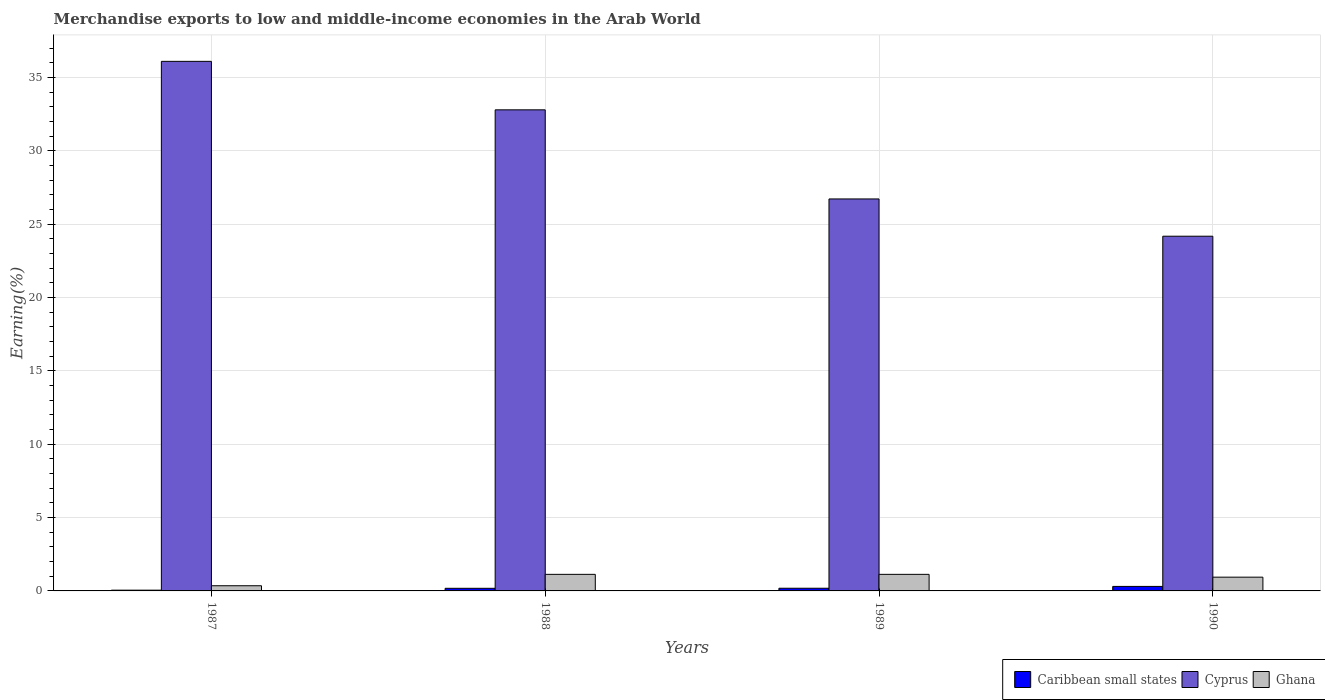Are the number of bars per tick equal to the number of legend labels?
Provide a short and direct response. Yes. Are the number of bars on each tick of the X-axis equal?
Offer a very short reply. Yes. In how many cases, is the number of bars for a given year not equal to the number of legend labels?
Provide a succinct answer. 0. What is the percentage of amount earned from merchandise exports in Ghana in 1989?
Your answer should be compact. 1.13. Across all years, what is the maximum percentage of amount earned from merchandise exports in Ghana?
Your response must be concise. 1.13. Across all years, what is the minimum percentage of amount earned from merchandise exports in Caribbean small states?
Your answer should be compact. 0.05. In which year was the percentage of amount earned from merchandise exports in Ghana minimum?
Provide a short and direct response. 1987. What is the total percentage of amount earned from merchandise exports in Caribbean small states in the graph?
Provide a succinct answer. 0.72. What is the difference between the percentage of amount earned from merchandise exports in Ghana in 1989 and that in 1990?
Ensure brevity in your answer.  0.19. What is the difference between the percentage of amount earned from merchandise exports in Ghana in 1988 and the percentage of amount earned from merchandise exports in Cyprus in 1989?
Your answer should be compact. -25.6. What is the average percentage of amount earned from merchandise exports in Cyprus per year?
Give a very brief answer. 29.95. In the year 1987, what is the difference between the percentage of amount earned from merchandise exports in Cyprus and percentage of amount earned from merchandise exports in Caribbean small states?
Keep it short and to the point. 36.06. What is the ratio of the percentage of amount earned from merchandise exports in Ghana in 1987 to that in 1988?
Ensure brevity in your answer.  0.31. Is the difference between the percentage of amount earned from merchandise exports in Cyprus in 1989 and 1990 greater than the difference between the percentage of amount earned from merchandise exports in Caribbean small states in 1989 and 1990?
Your answer should be compact. Yes. What is the difference between the highest and the second highest percentage of amount earned from merchandise exports in Cyprus?
Keep it short and to the point. 3.31. What is the difference between the highest and the lowest percentage of amount earned from merchandise exports in Ghana?
Your answer should be very brief. 0.78. In how many years, is the percentage of amount earned from merchandise exports in Caribbean small states greater than the average percentage of amount earned from merchandise exports in Caribbean small states taken over all years?
Give a very brief answer. 2. Is the sum of the percentage of amount earned from merchandise exports in Caribbean small states in 1987 and 1989 greater than the maximum percentage of amount earned from merchandise exports in Ghana across all years?
Ensure brevity in your answer.  No. What does the 3rd bar from the right in 1990 represents?
Your answer should be compact. Caribbean small states. Is it the case that in every year, the sum of the percentage of amount earned from merchandise exports in Caribbean small states and percentage of amount earned from merchandise exports in Cyprus is greater than the percentage of amount earned from merchandise exports in Ghana?
Keep it short and to the point. Yes. How many years are there in the graph?
Provide a short and direct response. 4. Does the graph contain any zero values?
Offer a very short reply. No. Where does the legend appear in the graph?
Your answer should be very brief. Bottom right. How are the legend labels stacked?
Make the answer very short. Horizontal. What is the title of the graph?
Your response must be concise. Merchandise exports to low and middle-income economies in the Arab World. Does "Lao PDR" appear as one of the legend labels in the graph?
Offer a terse response. No. What is the label or title of the Y-axis?
Ensure brevity in your answer.  Earning(%). What is the Earning(%) in Caribbean small states in 1987?
Provide a succinct answer. 0.05. What is the Earning(%) of Cyprus in 1987?
Keep it short and to the point. 36.11. What is the Earning(%) in Ghana in 1987?
Your answer should be very brief. 0.35. What is the Earning(%) in Caribbean small states in 1988?
Your answer should be very brief. 0.18. What is the Earning(%) of Cyprus in 1988?
Keep it short and to the point. 32.8. What is the Earning(%) of Ghana in 1988?
Provide a succinct answer. 1.13. What is the Earning(%) in Caribbean small states in 1989?
Offer a terse response. 0.18. What is the Earning(%) in Cyprus in 1989?
Your response must be concise. 26.73. What is the Earning(%) in Ghana in 1989?
Offer a terse response. 1.13. What is the Earning(%) in Caribbean small states in 1990?
Offer a terse response. 0.31. What is the Earning(%) in Cyprus in 1990?
Your answer should be very brief. 24.18. What is the Earning(%) of Ghana in 1990?
Give a very brief answer. 0.94. Across all years, what is the maximum Earning(%) in Caribbean small states?
Your response must be concise. 0.31. Across all years, what is the maximum Earning(%) in Cyprus?
Your response must be concise. 36.11. Across all years, what is the maximum Earning(%) in Ghana?
Provide a short and direct response. 1.13. Across all years, what is the minimum Earning(%) in Caribbean small states?
Ensure brevity in your answer.  0.05. Across all years, what is the minimum Earning(%) in Cyprus?
Make the answer very short. 24.18. Across all years, what is the minimum Earning(%) of Ghana?
Provide a succinct answer. 0.35. What is the total Earning(%) of Caribbean small states in the graph?
Make the answer very short. 0.72. What is the total Earning(%) of Cyprus in the graph?
Keep it short and to the point. 119.82. What is the total Earning(%) in Ghana in the graph?
Keep it short and to the point. 3.55. What is the difference between the Earning(%) in Caribbean small states in 1987 and that in 1988?
Offer a terse response. -0.13. What is the difference between the Earning(%) of Cyprus in 1987 and that in 1988?
Keep it short and to the point. 3.31. What is the difference between the Earning(%) of Ghana in 1987 and that in 1988?
Ensure brevity in your answer.  -0.78. What is the difference between the Earning(%) of Caribbean small states in 1987 and that in 1989?
Keep it short and to the point. -0.13. What is the difference between the Earning(%) of Cyprus in 1987 and that in 1989?
Provide a short and direct response. 9.38. What is the difference between the Earning(%) of Ghana in 1987 and that in 1989?
Your response must be concise. -0.78. What is the difference between the Earning(%) of Caribbean small states in 1987 and that in 1990?
Provide a short and direct response. -0.26. What is the difference between the Earning(%) in Cyprus in 1987 and that in 1990?
Offer a very short reply. 11.92. What is the difference between the Earning(%) of Ghana in 1987 and that in 1990?
Your answer should be compact. -0.59. What is the difference between the Earning(%) in Caribbean small states in 1988 and that in 1989?
Your answer should be compact. -0. What is the difference between the Earning(%) in Cyprus in 1988 and that in 1989?
Your answer should be compact. 6.08. What is the difference between the Earning(%) of Caribbean small states in 1988 and that in 1990?
Offer a terse response. -0.13. What is the difference between the Earning(%) in Cyprus in 1988 and that in 1990?
Offer a terse response. 8.62. What is the difference between the Earning(%) in Ghana in 1988 and that in 1990?
Keep it short and to the point. 0.19. What is the difference between the Earning(%) in Caribbean small states in 1989 and that in 1990?
Provide a short and direct response. -0.12. What is the difference between the Earning(%) in Cyprus in 1989 and that in 1990?
Offer a terse response. 2.54. What is the difference between the Earning(%) in Ghana in 1989 and that in 1990?
Make the answer very short. 0.19. What is the difference between the Earning(%) of Caribbean small states in 1987 and the Earning(%) of Cyprus in 1988?
Provide a short and direct response. -32.75. What is the difference between the Earning(%) of Caribbean small states in 1987 and the Earning(%) of Ghana in 1988?
Ensure brevity in your answer.  -1.08. What is the difference between the Earning(%) in Cyprus in 1987 and the Earning(%) in Ghana in 1988?
Your response must be concise. 34.98. What is the difference between the Earning(%) in Caribbean small states in 1987 and the Earning(%) in Cyprus in 1989?
Offer a terse response. -26.67. What is the difference between the Earning(%) of Caribbean small states in 1987 and the Earning(%) of Ghana in 1989?
Provide a short and direct response. -1.08. What is the difference between the Earning(%) in Cyprus in 1987 and the Earning(%) in Ghana in 1989?
Offer a terse response. 34.98. What is the difference between the Earning(%) of Caribbean small states in 1987 and the Earning(%) of Cyprus in 1990?
Your answer should be compact. -24.13. What is the difference between the Earning(%) in Caribbean small states in 1987 and the Earning(%) in Ghana in 1990?
Provide a succinct answer. -0.89. What is the difference between the Earning(%) of Cyprus in 1987 and the Earning(%) of Ghana in 1990?
Your response must be concise. 35.17. What is the difference between the Earning(%) of Caribbean small states in 1988 and the Earning(%) of Cyprus in 1989?
Make the answer very short. -26.55. What is the difference between the Earning(%) in Caribbean small states in 1988 and the Earning(%) in Ghana in 1989?
Make the answer very short. -0.95. What is the difference between the Earning(%) in Cyprus in 1988 and the Earning(%) in Ghana in 1989?
Ensure brevity in your answer.  31.67. What is the difference between the Earning(%) of Caribbean small states in 1988 and the Earning(%) of Cyprus in 1990?
Offer a terse response. -24.01. What is the difference between the Earning(%) of Caribbean small states in 1988 and the Earning(%) of Ghana in 1990?
Give a very brief answer. -0.76. What is the difference between the Earning(%) in Cyprus in 1988 and the Earning(%) in Ghana in 1990?
Keep it short and to the point. 31.86. What is the difference between the Earning(%) in Caribbean small states in 1989 and the Earning(%) in Cyprus in 1990?
Your response must be concise. -24. What is the difference between the Earning(%) of Caribbean small states in 1989 and the Earning(%) of Ghana in 1990?
Offer a terse response. -0.76. What is the difference between the Earning(%) of Cyprus in 1989 and the Earning(%) of Ghana in 1990?
Make the answer very short. 25.79. What is the average Earning(%) in Caribbean small states per year?
Your answer should be compact. 0.18. What is the average Earning(%) of Cyprus per year?
Give a very brief answer. 29.95. What is the average Earning(%) of Ghana per year?
Offer a terse response. 0.89. In the year 1987, what is the difference between the Earning(%) of Caribbean small states and Earning(%) of Cyprus?
Offer a terse response. -36.06. In the year 1987, what is the difference between the Earning(%) of Caribbean small states and Earning(%) of Ghana?
Offer a very short reply. -0.3. In the year 1987, what is the difference between the Earning(%) of Cyprus and Earning(%) of Ghana?
Your response must be concise. 35.75. In the year 1988, what is the difference between the Earning(%) of Caribbean small states and Earning(%) of Cyprus?
Make the answer very short. -32.62. In the year 1988, what is the difference between the Earning(%) in Caribbean small states and Earning(%) in Ghana?
Keep it short and to the point. -0.95. In the year 1988, what is the difference between the Earning(%) of Cyprus and Earning(%) of Ghana?
Your response must be concise. 31.67. In the year 1989, what is the difference between the Earning(%) of Caribbean small states and Earning(%) of Cyprus?
Your answer should be very brief. -26.54. In the year 1989, what is the difference between the Earning(%) in Caribbean small states and Earning(%) in Ghana?
Your answer should be compact. -0.95. In the year 1989, what is the difference between the Earning(%) of Cyprus and Earning(%) of Ghana?
Give a very brief answer. 25.6. In the year 1990, what is the difference between the Earning(%) in Caribbean small states and Earning(%) in Cyprus?
Provide a succinct answer. -23.88. In the year 1990, what is the difference between the Earning(%) in Caribbean small states and Earning(%) in Ghana?
Offer a terse response. -0.63. In the year 1990, what is the difference between the Earning(%) of Cyprus and Earning(%) of Ghana?
Offer a very short reply. 23.25. What is the ratio of the Earning(%) of Caribbean small states in 1987 to that in 1988?
Provide a short and direct response. 0.29. What is the ratio of the Earning(%) of Cyprus in 1987 to that in 1988?
Keep it short and to the point. 1.1. What is the ratio of the Earning(%) in Ghana in 1987 to that in 1988?
Provide a succinct answer. 0.31. What is the ratio of the Earning(%) of Caribbean small states in 1987 to that in 1989?
Your answer should be very brief. 0.28. What is the ratio of the Earning(%) in Cyprus in 1987 to that in 1989?
Provide a short and direct response. 1.35. What is the ratio of the Earning(%) of Ghana in 1987 to that in 1989?
Your answer should be very brief. 0.31. What is the ratio of the Earning(%) of Caribbean small states in 1987 to that in 1990?
Offer a terse response. 0.17. What is the ratio of the Earning(%) in Cyprus in 1987 to that in 1990?
Your answer should be very brief. 1.49. What is the ratio of the Earning(%) in Ghana in 1987 to that in 1990?
Your response must be concise. 0.38. What is the ratio of the Earning(%) in Caribbean small states in 1988 to that in 1989?
Your answer should be very brief. 0.98. What is the ratio of the Earning(%) in Cyprus in 1988 to that in 1989?
Make the answer very short. 1.23. What is the ratio of the Earning(%) of Caribbean small states in 1988 to that in 1990?
Provide a succinct answer. 0.58. What is the ratio of the Earning(%) of Cyprus in 1988 to that in 1990?
Ensure brevity in your answer.  1.36. What is the ratio of the Earning(%) of Ghana in 1988 to that in 1990?
Your answer should be compact. 1.2. What is the ratio of the Earning(%) of Caribbean small states in 1989 to that in 1990?
Provide a succinct answer. 0.59. What is the ratio of the Earning(%) of Cyprus in 1989 to that in 1990?
Your response must be concise. 1.11. What is the ratio of the Earning(%) in Ghana in 1989 to that in 1990?
Your answer should be compact. 1.2. What is the difference between the highest and the second highest Earning(%) of Caribbean small states?
Give a very brief answer. 0.12. What is the difference between the highest and the second highest Earning(%) of Cyprus?
Make the answer very short. 3.31. What is the difference between the highest and the lowest Earning(%) of Caribbean small states?
Provide a succinct answer. 0.26. What is the difference between the highest and the lowest Earning(%) of Cyprus?
Provide a short and direct response. 11.92. What is the difference between the highest and the lowest Earning(%) of Ghana?
Make the answer very short. 0.78. 